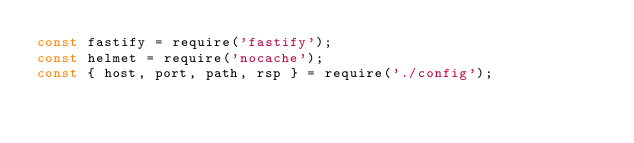<code> <loc_0><loc_0><loc_500><loc_500><_JavaScript_>const fastify = require('fastify');
const helmet = require('nocache');
const { host, port, path, rsp } = require('./config');
</code> 